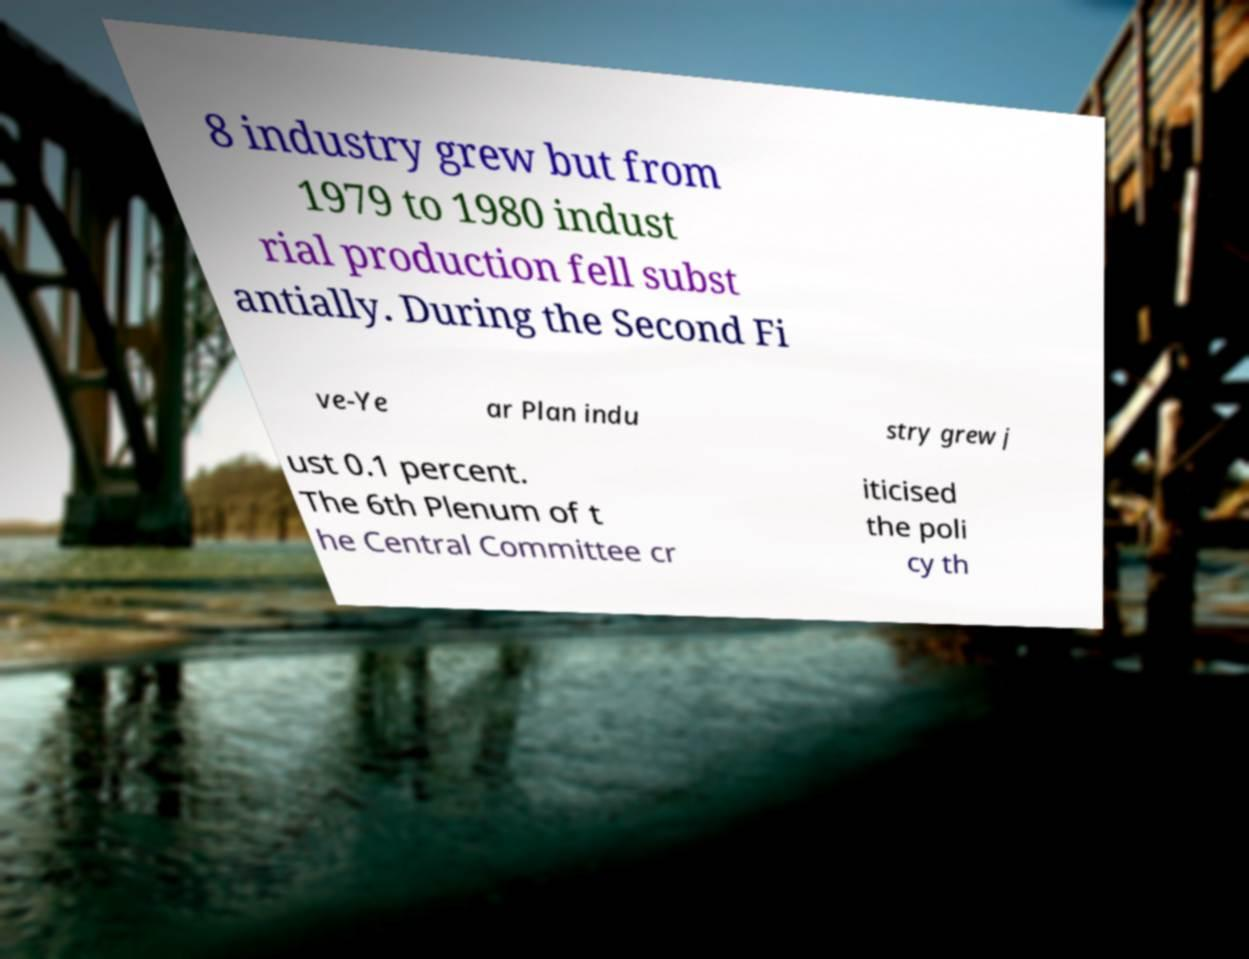Please identify and transcribe the text found in this image. 8 industry grew but from 1979 to 1980 indust rial production fell subst antially. During the Second Fi ve-Ye ar Plan indu stry grew j ust 0.1 percent. The 6th Plenum of t he Central Committee cr iticised the poli cy th 